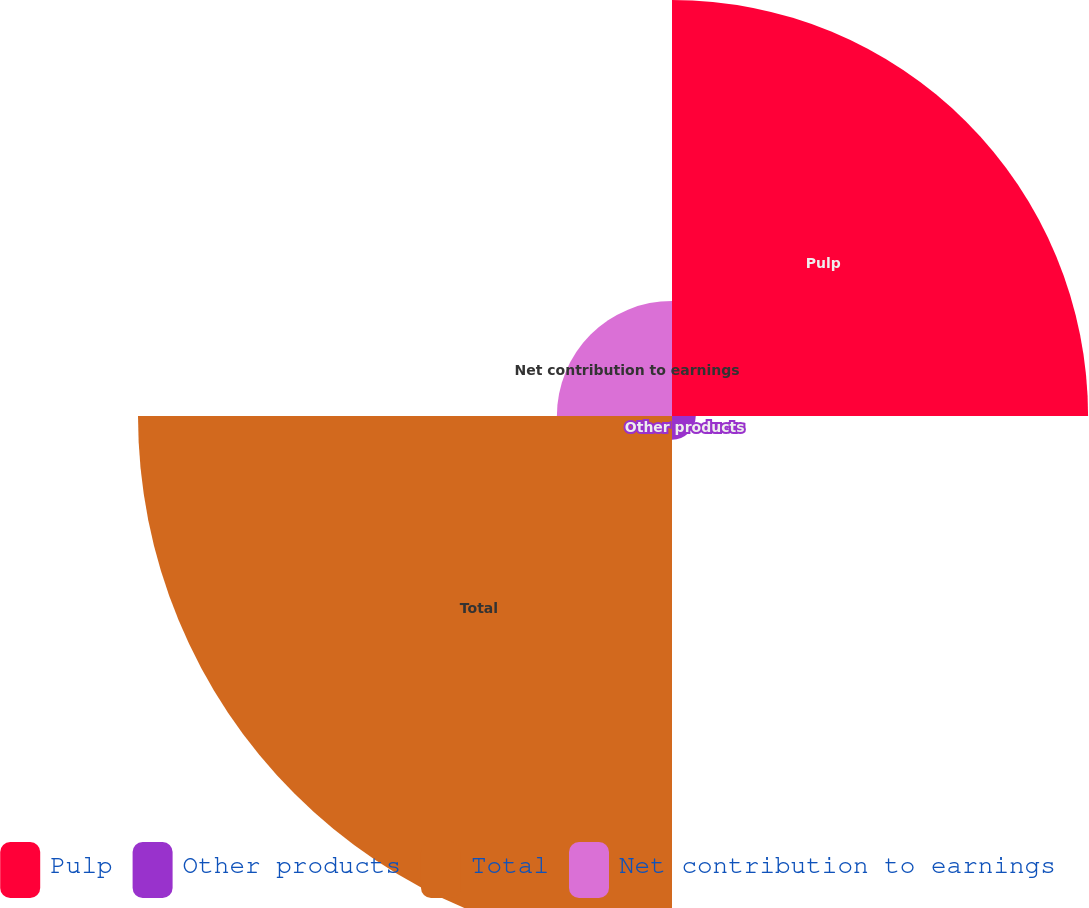<chart> <loc_0><loc_0><loc_500><loc_500><pie_chart><fcel>Pulp<fcel>Other products<fcel>Total<fcel>Net contribution to earnings<nl><fcel>38.21%<fcel>2.18%<fcel>49.04%<fcel>10.57%<nl></chart> 